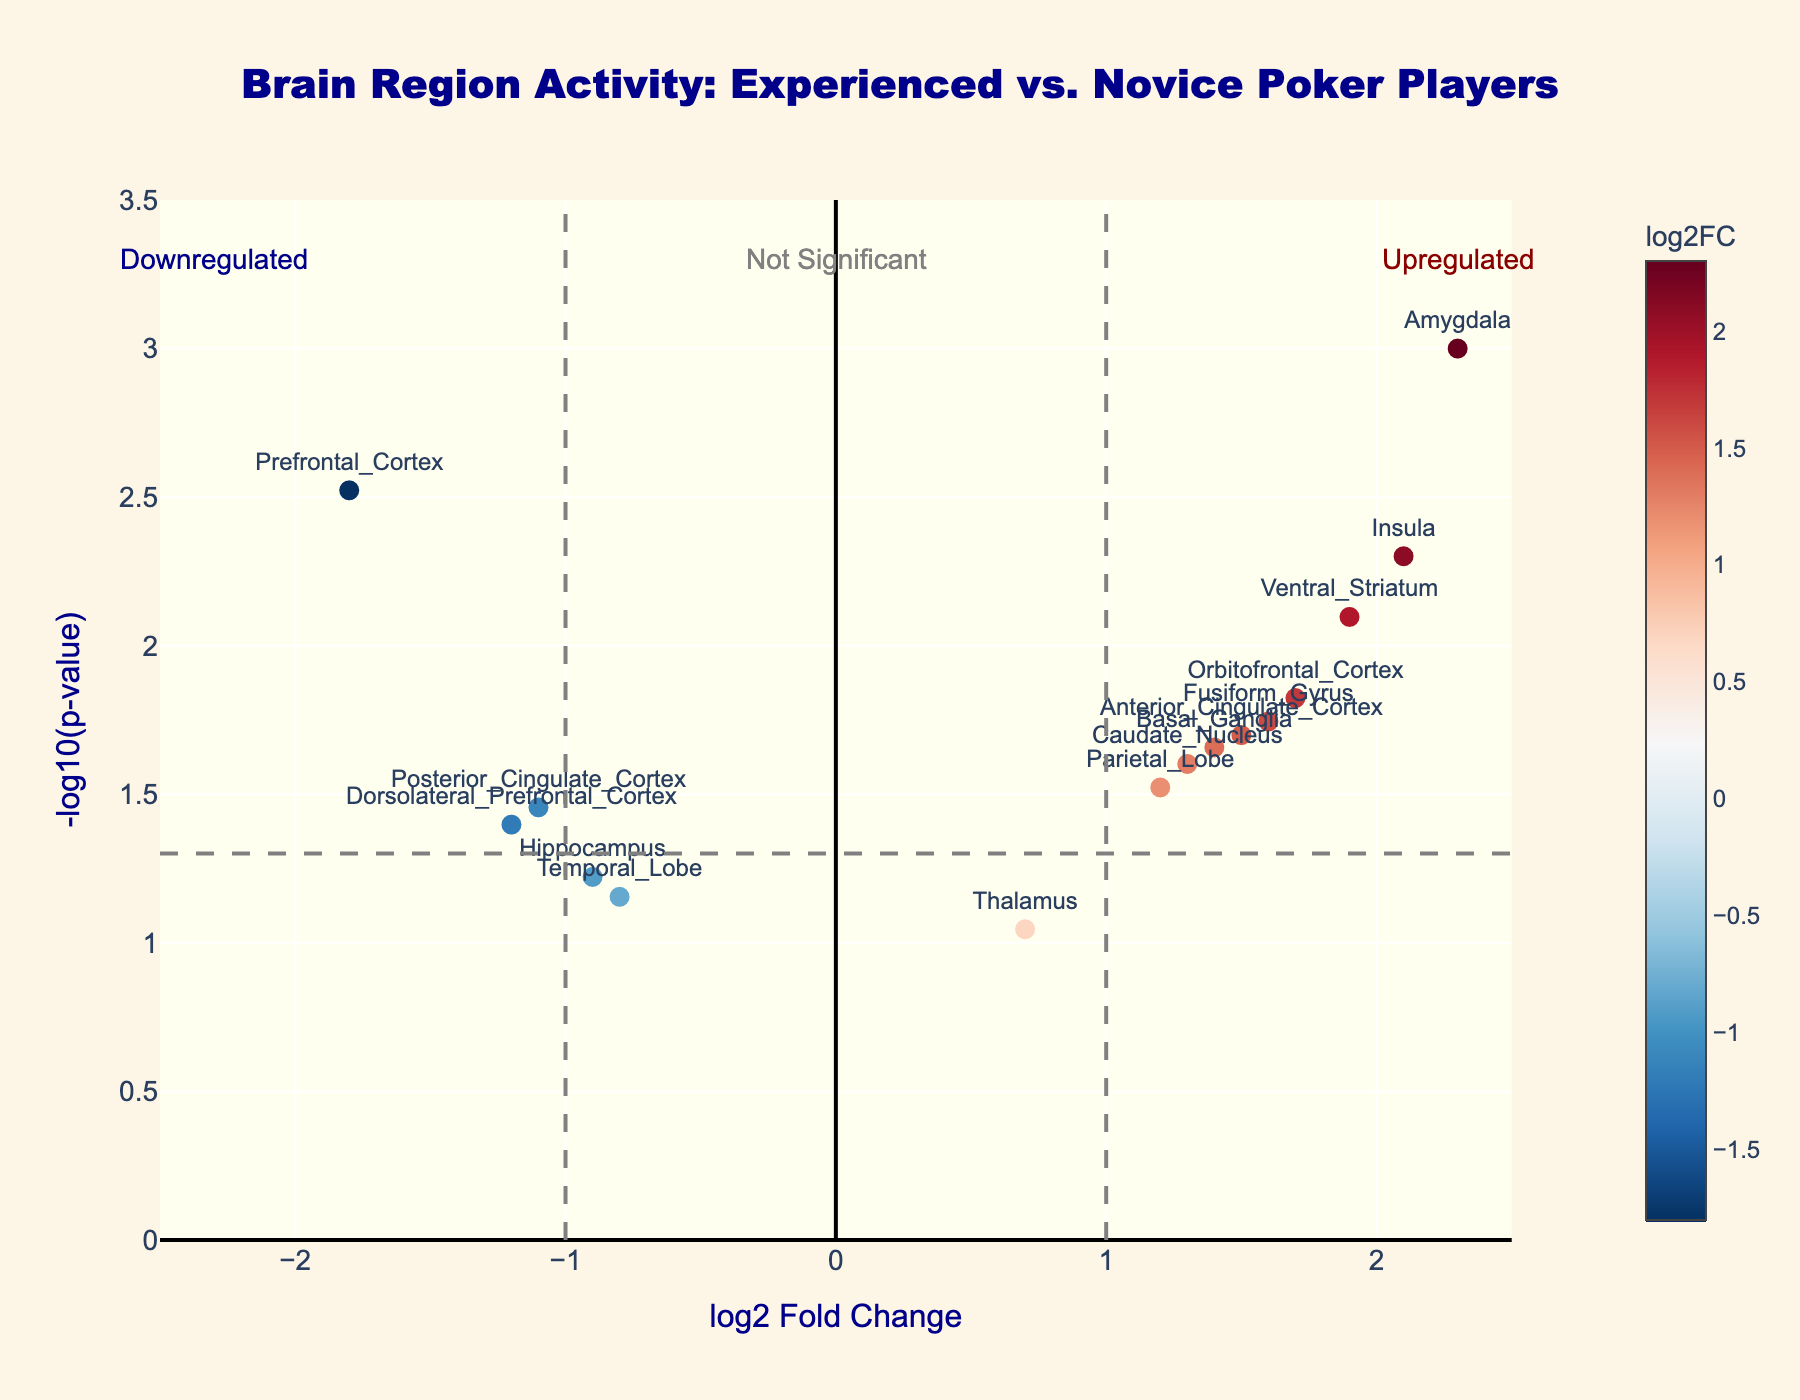What is the title of the figure? The title is typically displayed at the top of the figure. For this plot, it is: "Brain Region Activity: Experienced vs. Novice Poker Players".
Answer: Brain Region Activity: Experienced vs. Novice Poker Players Which gene has the highest -log10(p-value)? By examining the y-axis values, the Amygdala has the highest -log10(p-value) since its point is the furthest up on the plot around 3.
Answer: Amygdala How many genes fall within the upregulated category? The upregulated category is to the right of the vertical line at log2FoldChange = 1. By visually counting, we see Amygdala, Insula, Ventral_Striatum, Orbitofrontal_Cortex, Fusiform_Gyrus, Basal_Ganglia, Caudate_Nucleus, and Parietal_Lobe.
Answer: 8 Which gene appears to be the most downregulated? The most downregulated gene can be identified by finding the gene with the smallest log2FoldChange value. The Prefrontal_Cortex, at approximately -1.8, is the smallest value observed.
Answer: Prefrontal_Cortex Which gene has the lowest statistical significance? The gene with the lowest significance can be found by locating the gene with the smallest -log10(p-value). The Thalamus has the smallest value around 1.
Answer: Thalamus Which gene is closest to the log2FoldChange threshold of 1 on the upregulated side? Parietal_Lobe is closest to the threshold of log2FoldChange of 1 as its value is around 1.2.
Answer: Parietal_Lobe Does any gene fall into the 'not significant' category and on the upregulated side? The 'not significant' category lies below the horizontal line at -log10(p-value)=1.3 (p-value=0.05). Thalamus does not meet the significance threshold, but its log2FoldChange is positive, indicating it is on the upregulated side.
Answer: Thalamus Which brain regions have a log2FoldChange between -1 and 1? Brain regions with values between -1 and 1 are within the central vertical lines. These include Hippocampus, Temporal_Lobe, and Thalamus.
Answer: Hippocampus, Temporal_Lobe, and Thalamus What's the log2FoldChange for Insula, and how does it compare to Basal_Ganglia? The log2FoldChange for Insula is approximately 2.1 while for Basal_Ganglia, it's around 1.4. Insula is higher than Basal_Ganglia.
Answer: Insula has a higher log2FoldChange Which gene has a p-value around 0.01, and what is its corresponding -log10(p-value)? From the plot, -log10(0.01) is 2. Among the genes, Orbitofrontal_Cortex has around this value, as its -log10(p-value) is close to 2.
Answer: Orbitofrontal_Cortex, 2 